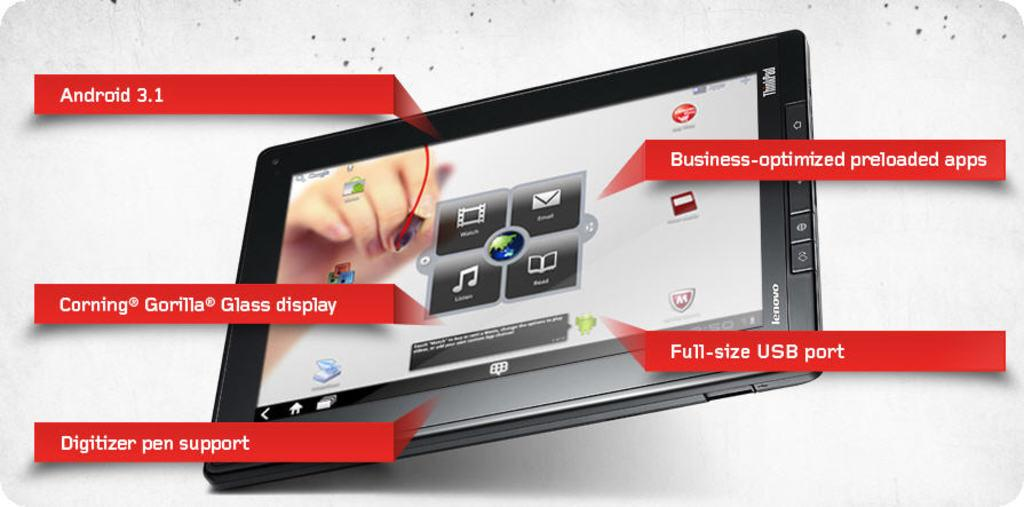Provide a one-sentence caption for the provided image. A lenovo tablet featuring Android 3.1, digital pen support, Full size USB port, Corning Gorilla Glass display and business optimized preloaded apps. 